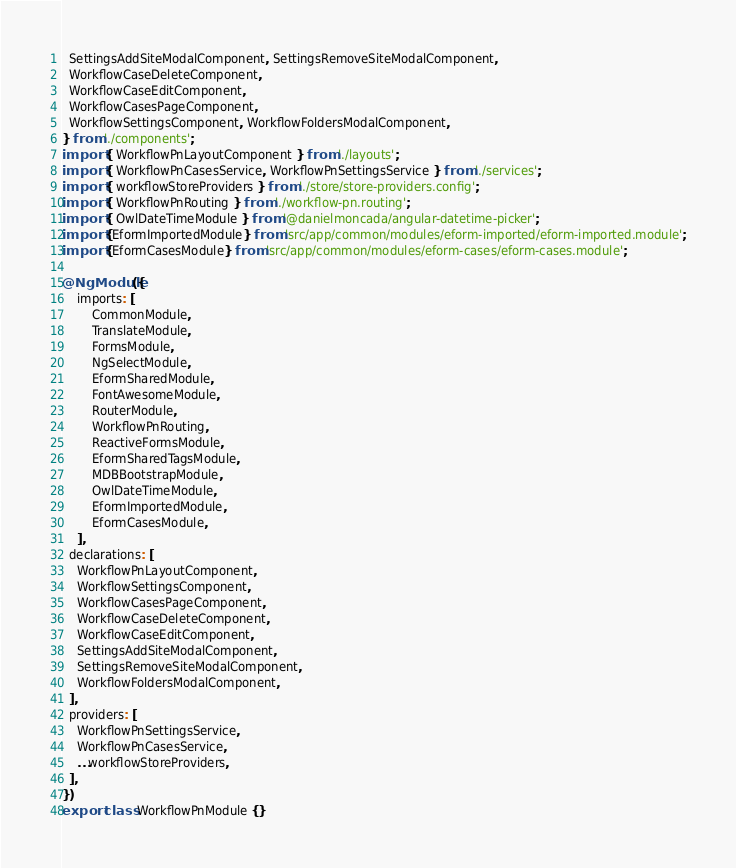Convert code to text. <code><loc_0><loc_0><loc_500><loc_500><_TypeScript_>  SettingsAddSiteModalComponent, SettingsRemoveSiteModalComponent,
  WorkflowCaseDeleteComponent,
  WorkflowCaseEditComponent,
  WorkflowCasesPageComponent,
  WorkflowSettingsComponent, WorkflowFoldersModalComponent,
} from './components';
import { WorkflowPnLayoutComponent } from './layouts';
import { WorkflowPnCasesService, WorkflowPnSettingsService } from './services';
import { workflowStoreProviders } from './store/store-providers.config';
import { WorkflowPnRouting } from './workflow-pn.routing';
import { OwlDateTimeModule } from '@danielmoncada/angular-datetime-picker';
import {EformImportedModule} from 'src/app/common/modules/eform-imported/eform-imported.module';
import {EformCasesModule} from 'src/app/common/modules/eform-cases/eform-cases.module';

@NgModule({
    imports: [
        CommonModule,
        TranslateModule,
        FormsModule,
        NgSelectModule,
        EformSharedModule,
        FontAwesomeModule,
        RouterModule,
        WorkflowPnRouting,
        ReactiveFormsModule,
        EformSharedTagsModule,
        MDBBootstrapModule,
        OwlDateTimeModule,
        EformImportedModule,
        EformCasesModule,
    ],
  declarations: [
    WorkflowPnLayoutComponent,
    WorkflowSettingsComponent,
    WorkflowCasesPageComponent,
    WorkflowCaseDeleteComponent,
    WorkflowCaseEditComponent,
    SettingsAddSiteModalComponent,
    SettingsRemoveSiteModalComponent,
    WorkflowFoldersModalComponent,
  ],
  providers: [
    WorkflowPnSettingsService,
    WorkflowPnCasesService,
    ...workflowStoreProviders,
  ],
})
export class WorkflowPnModule {}
</code> 